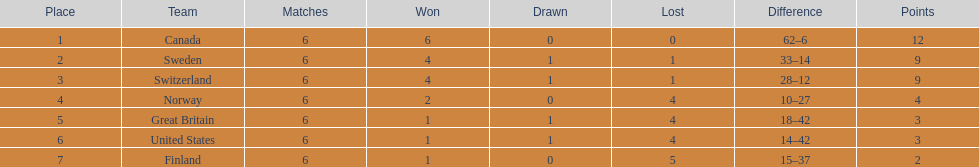What team positioned after canada? Sweden. 